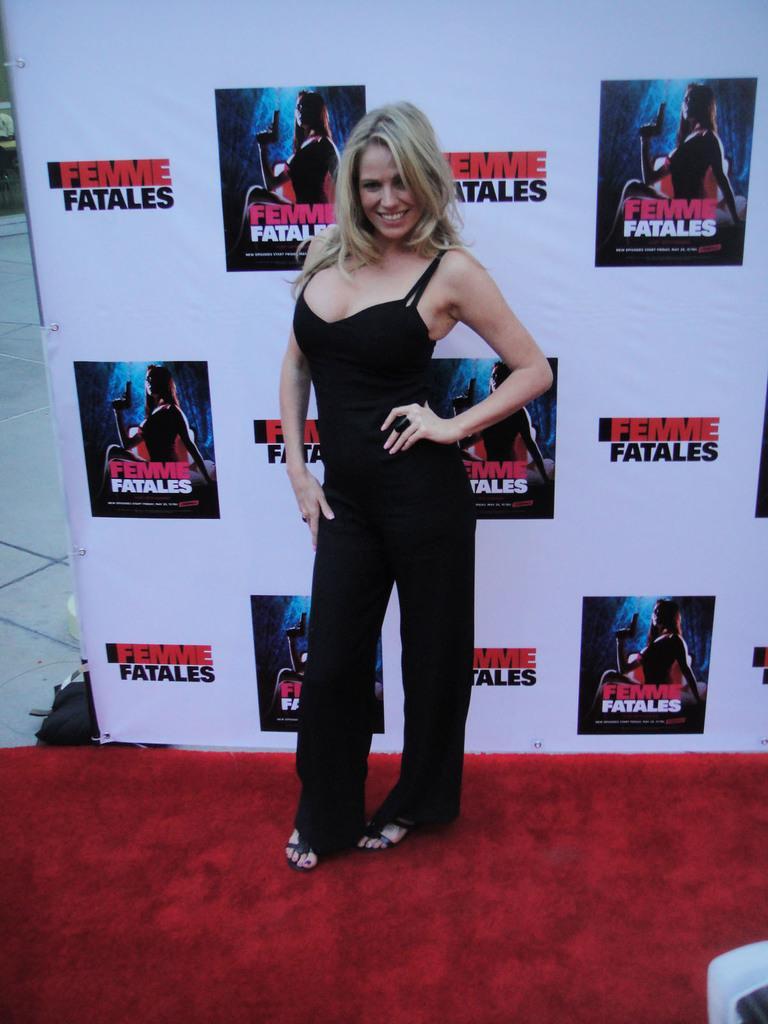Can you describe this image briefly? In this picture, we see a woman in the black dress is stunning. She is smiling and she is posing for the photo. At the bottom, we see a carpet in red color. Behind her, we see a board or a banner in white color with some text written on it. On the left side, we see the floor and a black bag. In the right bottom, we see an object in white color. 